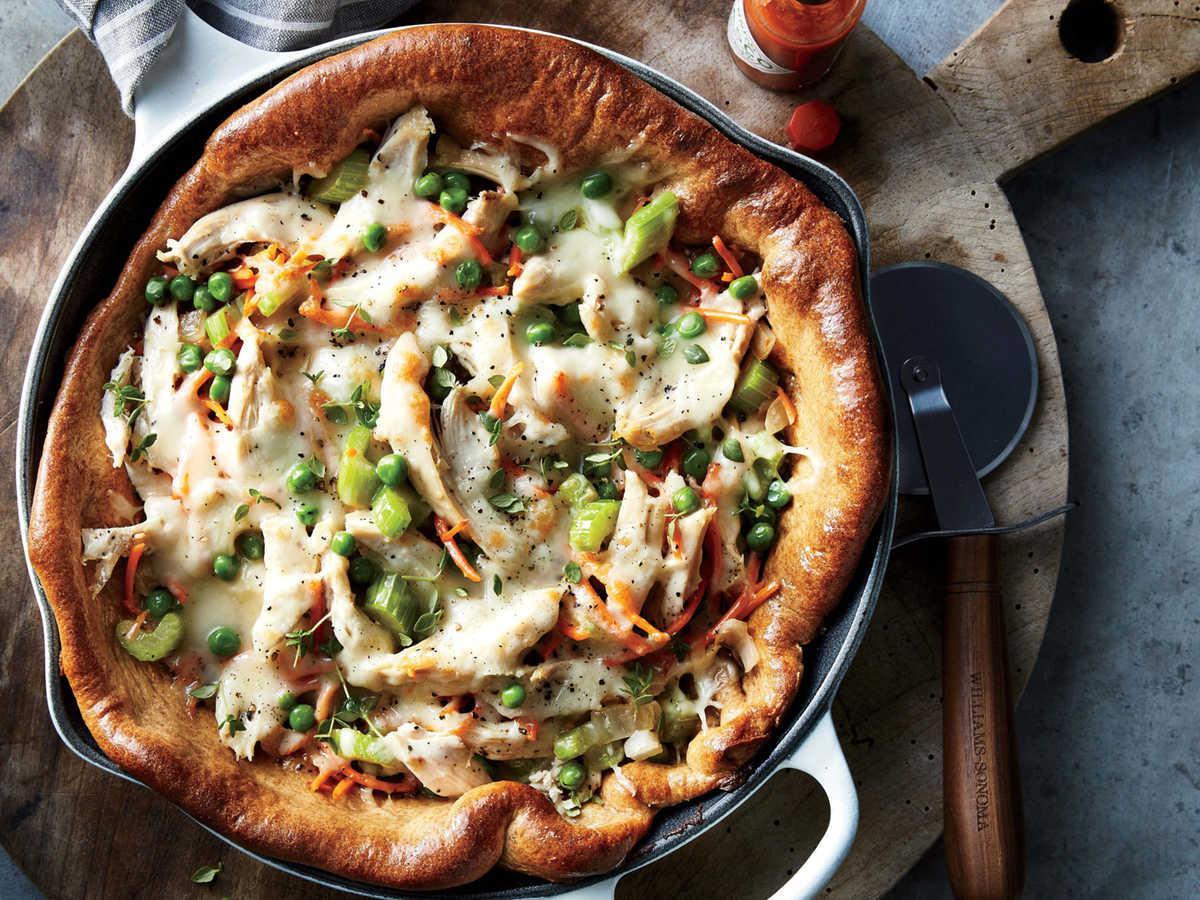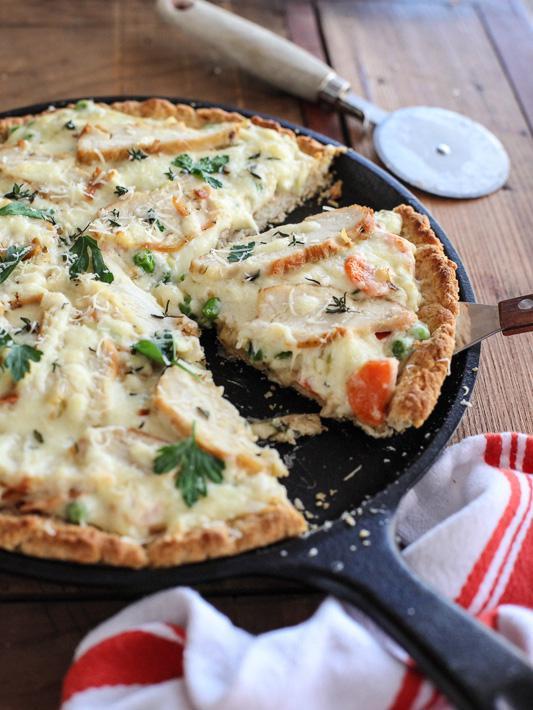The first image is the image on the left, the second image is the image on the right. Considering the images on both sides, is "There are two circle pizza with only one slice missing." valid? Answer yes or no. Yes. The first image is the image on the left, the second image is the image on the right. Considering the images on both sides, is "Two pizzas sit in black pans." valid? Answer yes or no. Yes. 